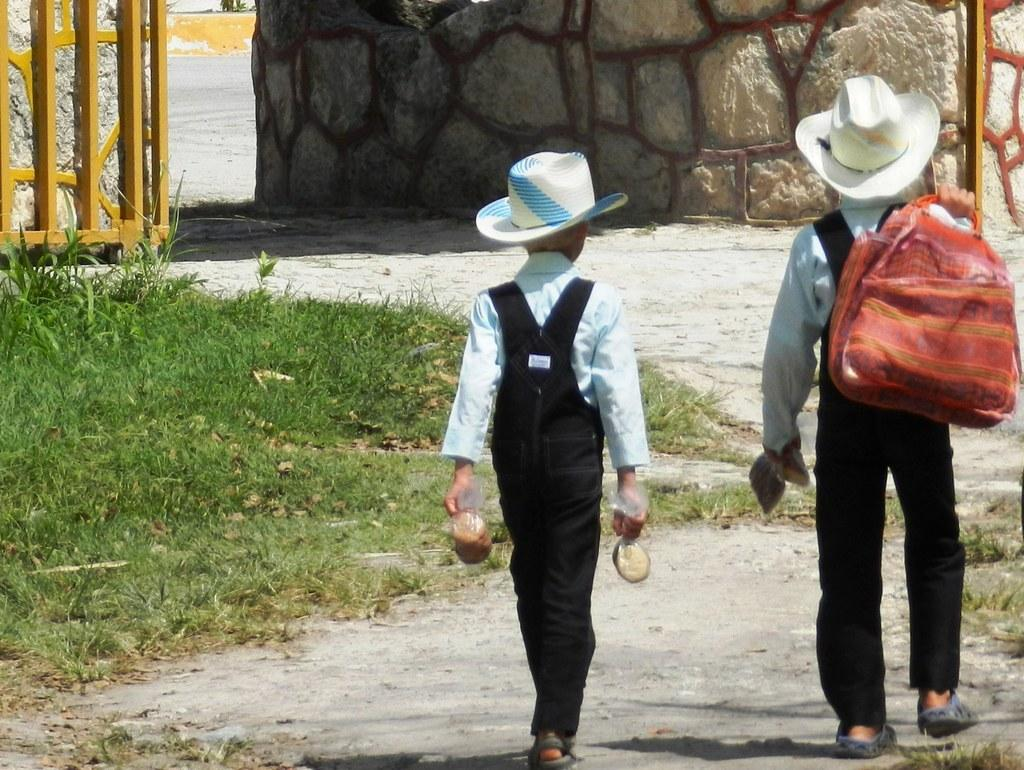How many boys are present in the image? There are two boys on the right side of the image. What can be seen on the left side of the image? There is greenery on the left side of the image. What structure is visible in the image? There is a gate in the image. What is located at the top side of the image? There is a wall at the top side of the image. We start by identifying the number of boys and their location in the image. Then, we describe the greenery on the left side. Next, we mention the gate as a structure present in the image. Finally, we identify the wall at the top side of the image. What type of metal is the father holding in the image? There is no father or metal object present in the image. Does the existence of the gate in the image prove the existence of a parallel universe? The presence of the gate in the image does not prove the existence of a parallel universe; it is simply a structure within the image. 